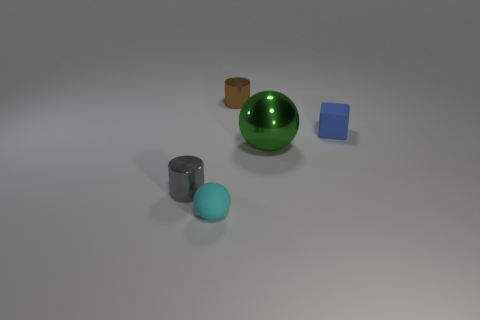Add 1 tiny yellow metal cylinders. How many objects exist? 6 Subtract all gray cylinders. How many cylinders are left? 1 Subtract all cubes. How many objects are left? 4 Subtract all brown cubes. Subtract all blue cylinders. How many cubes are left? 1 Subtract all purple spheres. How many yellow cylinders are left? 0 Subtract all tiny gray metallic cylinders. Subtract all matte balls. How many objects are left? 3 Add 5 tiny cyan spheres. How many tiny cyan spheres are left? 6 Add 2 tiny gray metallic objects. How many tiny gray metallic objects exist? 3 Subtract 0 green blocks. How many objects are left? 5 